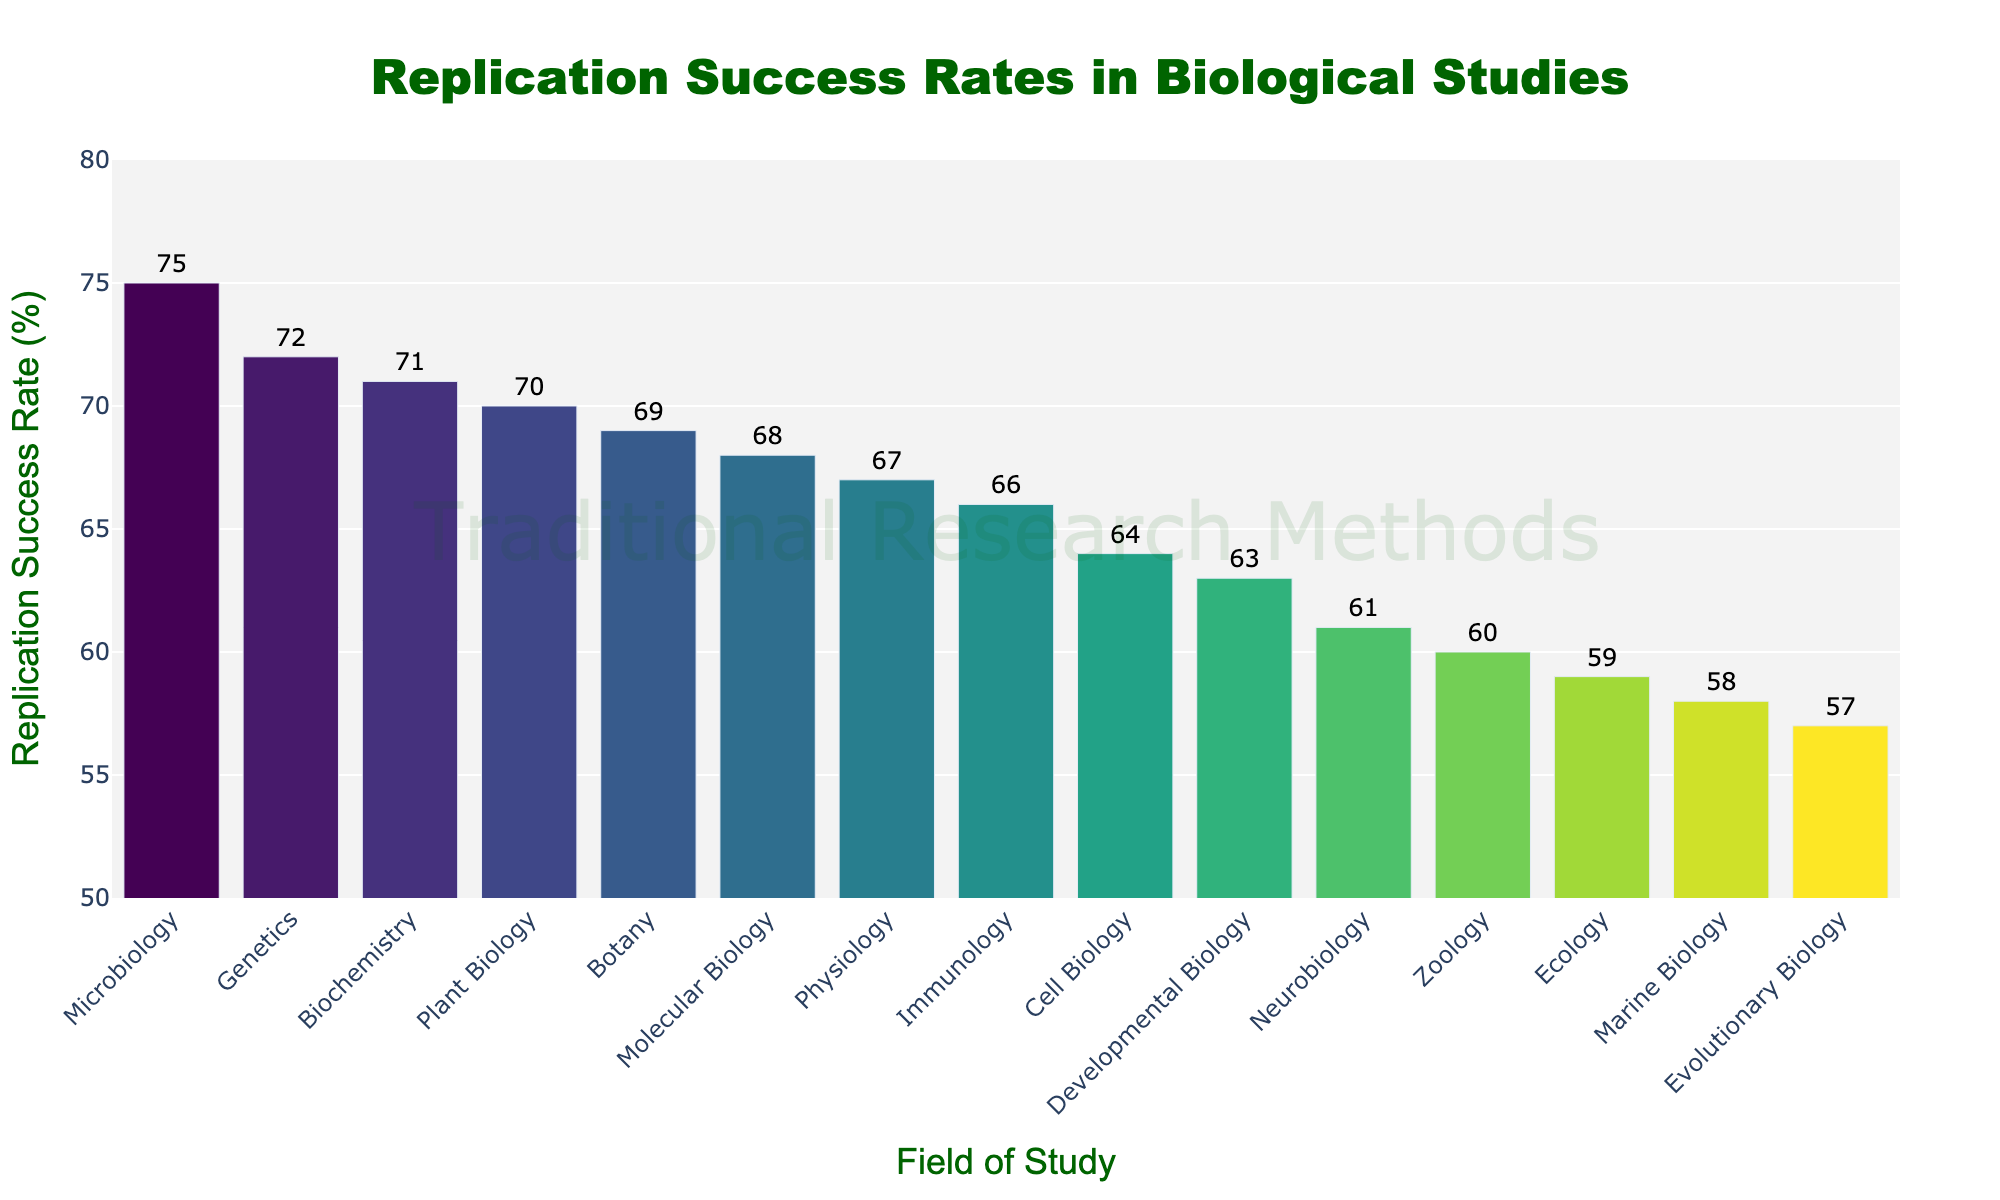Which field has the highest replication success rate? Look for the tallest bar in the bar chart. The tallest bar represents Microbiology, which has the highest replication success rate of 75%.
Answer: Microbiology Which field has a lower replication success rate: Neurobiology or Zoology? Check the height of the bars representing Neurobiology and Zoology. Neurobiology has a success rate of 61%, while Zoology has a success rate of 60%. Since 60% is lower than 61%, Zoology has the lower rate.
Answer: Zoology What is the median replication success rate across all fields of study? List all replication rates in ascending order: 57, 58, 59, 60, 61, 63, 64, 66, 67, 68, 69, 70, 71, 72, 75. The median value is the middle value in this ordered list, which is the 8th value in a list of 15, thus it is 66.
Answer: 66 Which field of study has the closest replication success rate to the median? The median replication success rate is 66%. Identify the field(s) with a replication success rate of 66%. Immunology has a success rate of 66%, which matches the median.
Answer: Immunology How much higher is the replication success rate in Biochemistry compared to Ecology? Check the replication rates for Biochemistry and Ecology. Biochemistry is 71% and Ecology is 59%. Subtract Ecology's rate from Biochemistry's rate: 71% - 59% = 12%.
Answer: 12% What is the range of replication success rates across all fields of study? Find the difference between the highest and lowest replication success rates. The highest rate is 75% (Microbiology) and the lowest is 57% (Evolutionary Biology). Subtract the lowest rate from the highest rate: 75% - 57% = 18 percentage points.
Answer: 18 percentage points Which fields have a replication success rate higher than 70%? Identify the fields with bars higher than the 70% mark. Genetics (72%), Biochemistry (71%), Plant Biology (70%), and Microbiology (75%) have replication rates higher than 70%.
Answer: Genetics, Biochemistry, Plant Biology, Microbiology What is the average replication success rate of Developmental Biology, Immunology, and Cell Biology? Find the replication success rates: Developmental Biology (63%), Immunology (66%), Cell Biology (64%). Sum these values: 63 + 66 + 64 = 193. Divide by the number of fields (3): 193 / 3 ≈ 64.3%.
Answer: 64.3% Does Botany have a replication success rate above or below the overall average rate? Calculate the overall average rate: (Sum of all rates) / 15 fields. Sum: 68+72+59+61+75+70+64+57+66+63+71+58+67+60+69 = 950. Average: 950 / 15 ≈ 63.3%. Since Botany has a replication rate of 69%, which is above 63.3%. Botany is above the overall average rate.
Answer: Above How many fields have a replication success rate between 60% and 70%? Count the number of fields with rates within the specified range: Molecular Biology (68%), Genetics (72%), Ecology (59%), Neurobiology (61%), Microbiology (75%), Plant Biology (70%), Cell Biology (64%), Evolutionary Biology (57%), Immunology (66%), Developmental Biology (63%), Biochemistry (71%), Marine Biology (58%), Physiology (67%), Zoology (60%), Botany (69%). The rates within 60% to 70% are Molecular Biology, Neurobiology, Cell Biology, Immunology, Developmental Biology, Physiology, Zoology, Botany, and Ecology, which means there are 9 fields.
Answer: 9 fields 